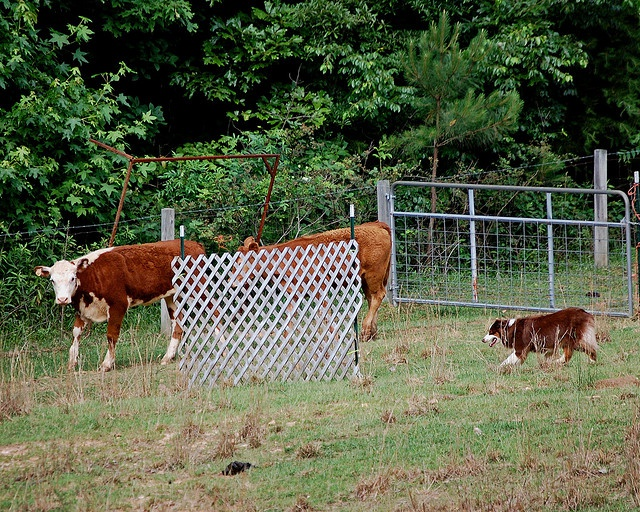Describe the objects in this image and their specific colors. I can see cow in darkgreen, lightgray, brown, darkgray, and maroon tones, cow in darkgreen, maroon, black, lightgray, and gray tones, dog in darkgreen, maroon, black, gray, and darkgray tones, and cow in darkgreen, gray, and tan tones in this image. 